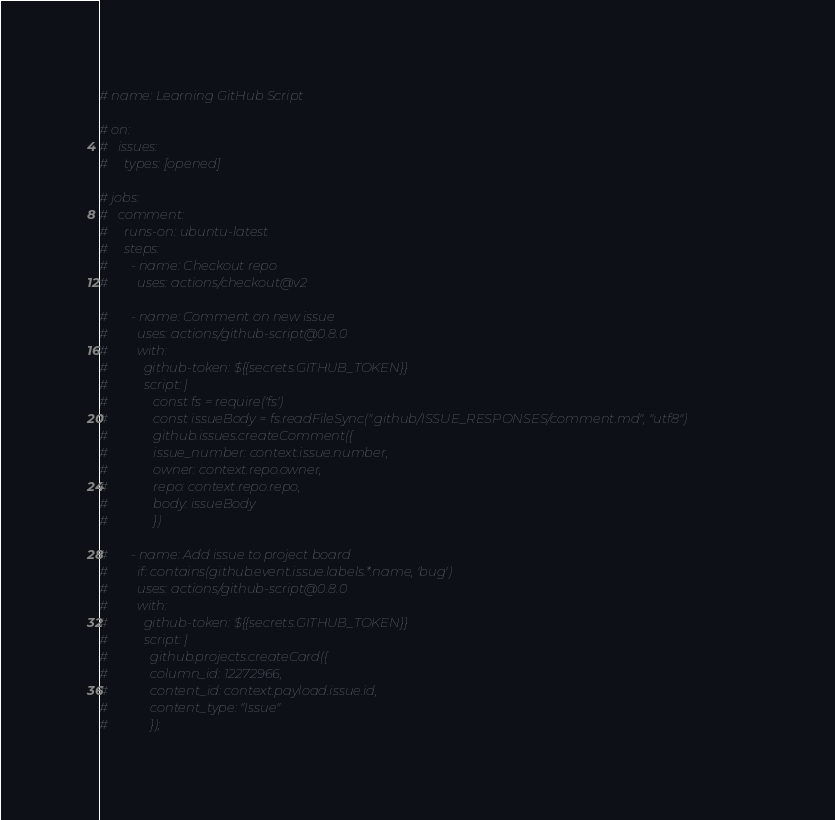<code> <loc_0><loc_0><loc_500><loc_500><_YAML_># name: Learning GitHub Script

# on:
#   issues:
#     types: [opened]

# jobs:
#   comment:
#     runs-on: ubuntu-latest
#     steps:
#       - name: Checkout repo
#         uses: actions/checkout@v2

#       - name: Comment on new issue
#         uses: actions/github-script@0.8.0
#         with:
#           github-token: ${{secrets.GITHUB_TOKEN}}
#           script: |
#              const fs = require('fs')
#              const issueBody = fs.readFileSync(".github/ISSUE_RESPONSES/comment.md", "utf8")
#              github.issues.createComment({
#              issue_number: context.issue.number,
#              owner: context.repo.owner,
#              repo: context.repo.repo,
#              body: issueBody
#              })

#       - name: Add issue to project board
#         if: contains(github.event.issue.labels.*.name, 'bug')
#         uses: actions/github-script@0.8.0
#         with:
#           github-token: ${{secrets.GITHUB_TOKEN}}
#           script: |
#             github.projects.createCard({
#             column_id: 12272966,
#             content_id: context.payload.issue.id,
#             content_type: "Issue"
#             });</code> 